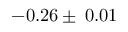<formula> <loc_0><loc_0><loc_500><loc_500>- 0 . 2 6 \pm \, 0 . 0 1</formula> 